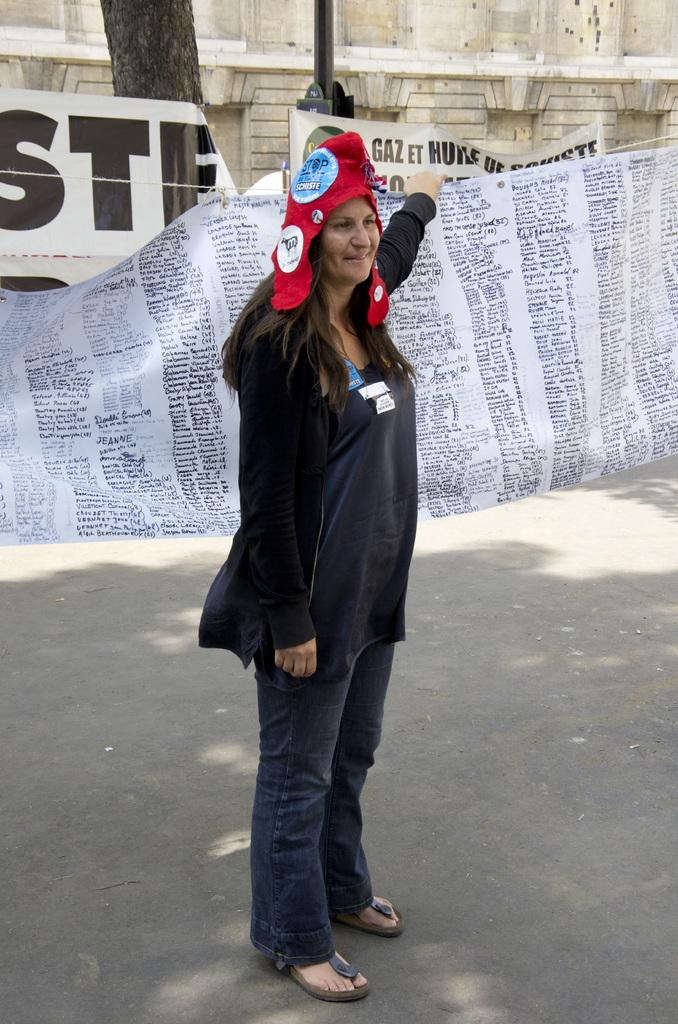What is the woman in the foreground of the image doing? The woman is standing in the foreground of the image and holding a banner. What can be seen in the background of the image? In the background of the image, there are banners, a tree trunk, a pole, and a wall. How many banners are visible in the image? There is one banner being held by the woman in the foreground, and there are additional banners visible in the background, so there are at least two banners in the image. What type of jam is being spread on the wall in the image? There is no jam present in the image; the wall is a part of the background and does not have any jam on it. 